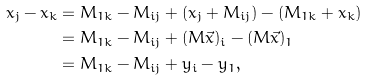<formula> <loc_0><loc_0><loc_500><loc_500>x _ { j } - x _ { k } & = M _ { 1 k } - M _ { i j } + ( x _ { j } + M _ { i j } ) - ( M _ { 1 k } + x _ { k } ) \\ & = M _ { 1 k } - M _ { i j } + ( M \vec { x } ) _ { i } - ( M \vec { x } ) _ { 1 } \\ & = M _ { 1 k } - M _ { i j } + y _ { i } - y _ { 1 } ,</formula> 